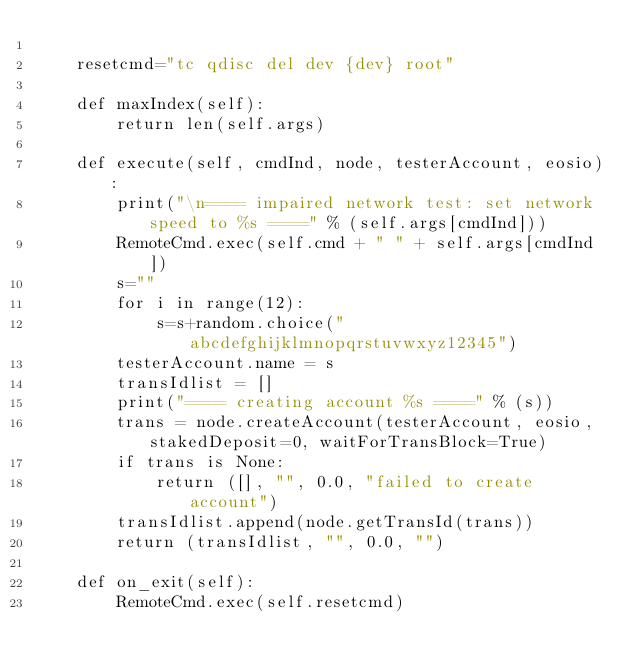<code> <loc_0><loc_0><loc_500><loc_500><_Python_>
    resetcmd="tc qdisc del dev {dev} root"

    def maxIndex(self):
        return len(self.args)

    def execute(self, cmdInd, node, testerAccount, eosio):
        print("\n==== impaired network test: set network speed to %s ====" % (self.args[cmdInd]))
        RemoteCmd.exec(self.cmd + " " + self.args[cmdInd])
        s=""
        for i in range(12):
            s=s+random.choice("abcdefghijklmnopqrstuvwxyz12345")
        testerAccount.name = s
        transIdlist = []
        print("==== creating account %s ====" % (s))
        trans = node.createAccount(testerAccount, eosio, stakedDeposit=0, waitForTransBlock=True)
        if trans is None:
            return ([], "", 0.0, "failed to create account")
        transIdlist.append(node.getTransId(trans))
        return (transIdlist, "", 0.0, "")
    
    def on_exit(self):
        RemoteCmd.exec(self.resetcmd)
</code> 